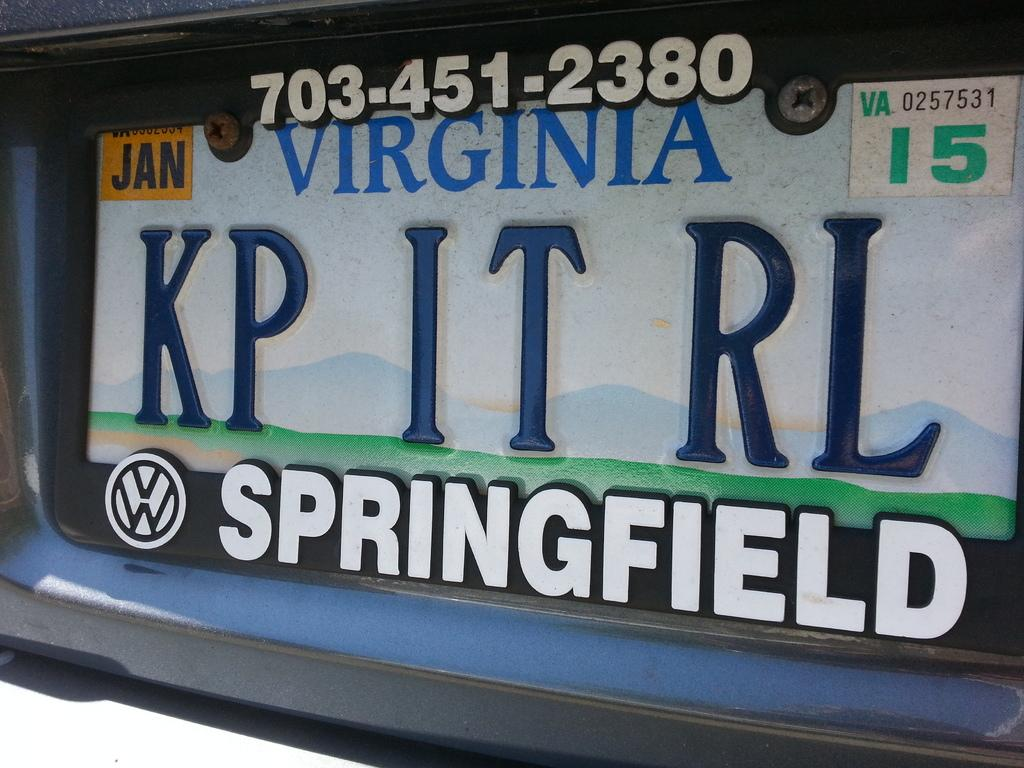<image>
Summarize the visual content of the image. Virginia license plate which says Springfield on it as well. 